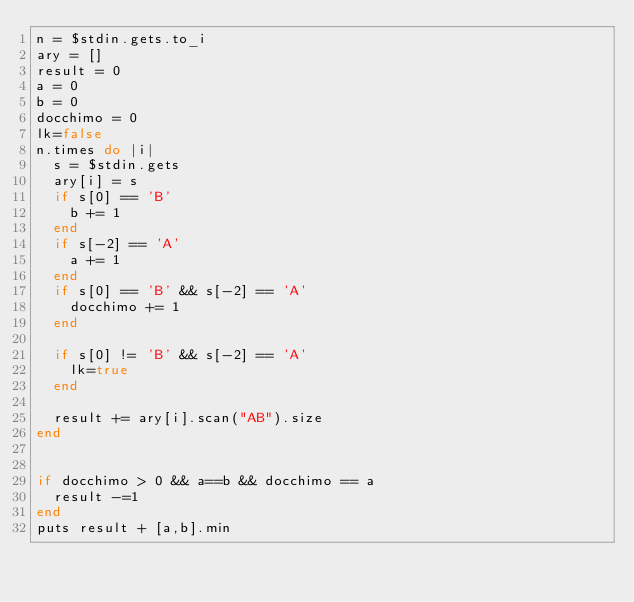<code> <loc_0><loc_0><loc_500><loc_500><_Ruby_>n = $stdin.gets.to_i
ary = []
result = 0
a = 0
b = 0
docchimo = 0
lk=false
n.times do |i|
  s = $stdin.gets
  ary[i] = s
  if s[0] == 'B'
    b += 1
  end
  if s[-2] == 'A'
    a += 1
  end
  if s[0] == 'B' && s[-2] == 'A'
    docchimo += 1
  end

  if s[0] != 'B' && s[-2] == 'A'
    lk=true
  end

  result += ary[i].scan("AB").size
end


if docchimo > 0 && a==b && docchimo == a
  result -=1
end
puts result + [a,b].min</code> 